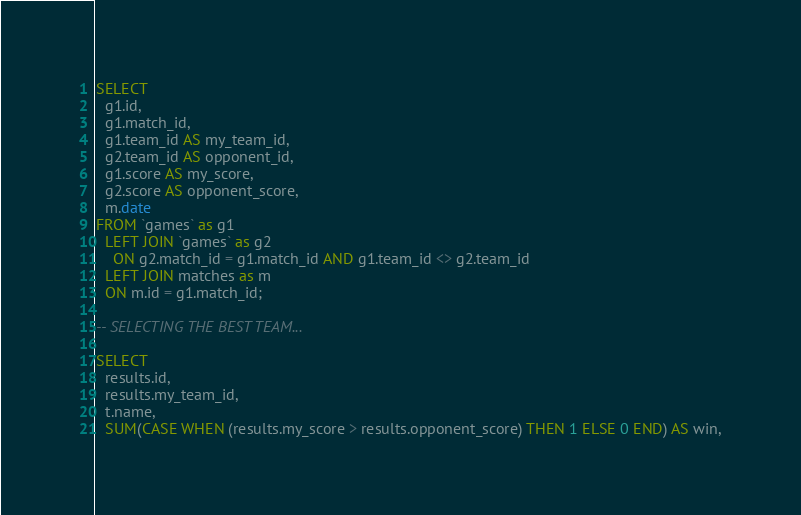Convert code to text. <code><loc_0><loc_0><loc_500><loc_500><_SQL_>SELECT
  g1.id,
  g1.match_id,
  g1.team_id AS my_team_id,
  g2.team_id AS opponent_id,
  g1.score AS my_score,
  g2.score AS opponent_score,
  m.date
FROM `games` as g1
  LEFT JOIN `games` as g2
    ON g2.match_id = g1.match_id AND g1.team_id <> g2.team_id
  LEFT JOIN matches as m
  ON m.id = g1.match_id;

-- SELECTING THE BEST TEAM...

SELECT
  results.id,
  results.my_team_id,
  t.name,
  SUM(CASE WHEN (results.my_score > results.opponent_score) THEN 1 ELSE 0 END) AS win,</code> 